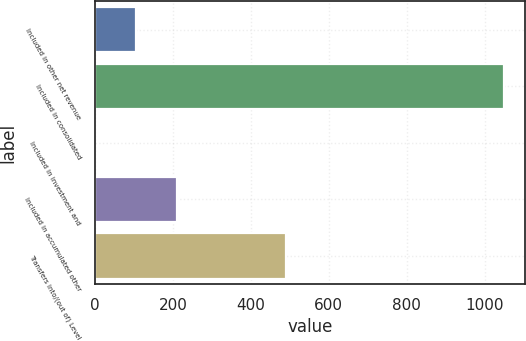Convert chart. <chart><loc_0><loc_0><loc_500><loc_500><bar_chart><fcel>Included in other net revenue<fcel>Included in consolidated<fcel>Included in investment and<fcel>Included in accumulated other<fcel>Transfers into/(out of) Level<nl><fcel>105.89<fcel>1050<fcel>0.99<fcel>210.79<fcel>489<nl></chart> 